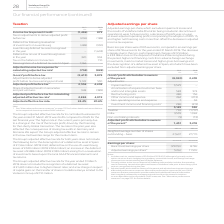According to Vodafone Group Plc's financial document, What was the reason for a higher adjusted effective tax rate in 2019? change in the mix of the Group’s profit, driven by the financing for the Liberty Global transaction. The document states: "er rate in the current year is primarily due to a change in the mix of the Group’s profit, driven by the financing for the Liberty Global transaction...." Also, How much is the income tax expense/credit in 2019? According to the financial document, (1,496) (in millions). The relevant text states: "2019 €m 2018 €m Income tax (expense)/credit: (1,496) 879 Tax on adjustments to derive adjusted profit before tax (206) (188) Deferred tax following reval..." Also, How much is the adjusted profit before tax in 2018? According to the financial document, 4,408 (in millions). The relevant text states: "are) 5,149 530 Adjusted profit before tax 1 2,536 4,408 Share of adjusted results in associates and joint ventures 348 (389) Adjusted profit before tax for..." Also, can you calculate: What is the average adjusted profit before tax? To answer this question, I need to perform calculations using the financial data. The calculation is: (2,536+4,408)/2, which equals 3472 (in millions). This is based on the information: "are) 5,149 530 Adjusted profit before tax 1 2,536 4,408 Share of adjusted results in associates and joint ventures 348 (389) Adjusted profit before tax for per share) 5,149 530 Adjusted profit before ..." The key data points involved are: 2,536, 4,408. Additionally, Which year has a higher Adjusted effective tax rate? According to the financial document, 2019. The relevant text states: "2019 €m 2018 €m Income tax (expense)/credit: (1,496) 879 Tax on adjustments to derive adjusted profit be..." Also, can you calculate: What is the average deferred tax on use of luxembourg losses? To answer this question, I need to perform calculations using the financial data. The calculation is: (320+304)/2, which equals 312 (in millions). This is based on the information: "erred tax on use of Luxembourg losses in the year 320 304 Tax on the Safaricom transaction – 110 Derecognition of a deferred tax asset in Spain 1,166 – A d tax on use of Luxembourg losses in the year ..." The key data points involved are: 304, 320. 